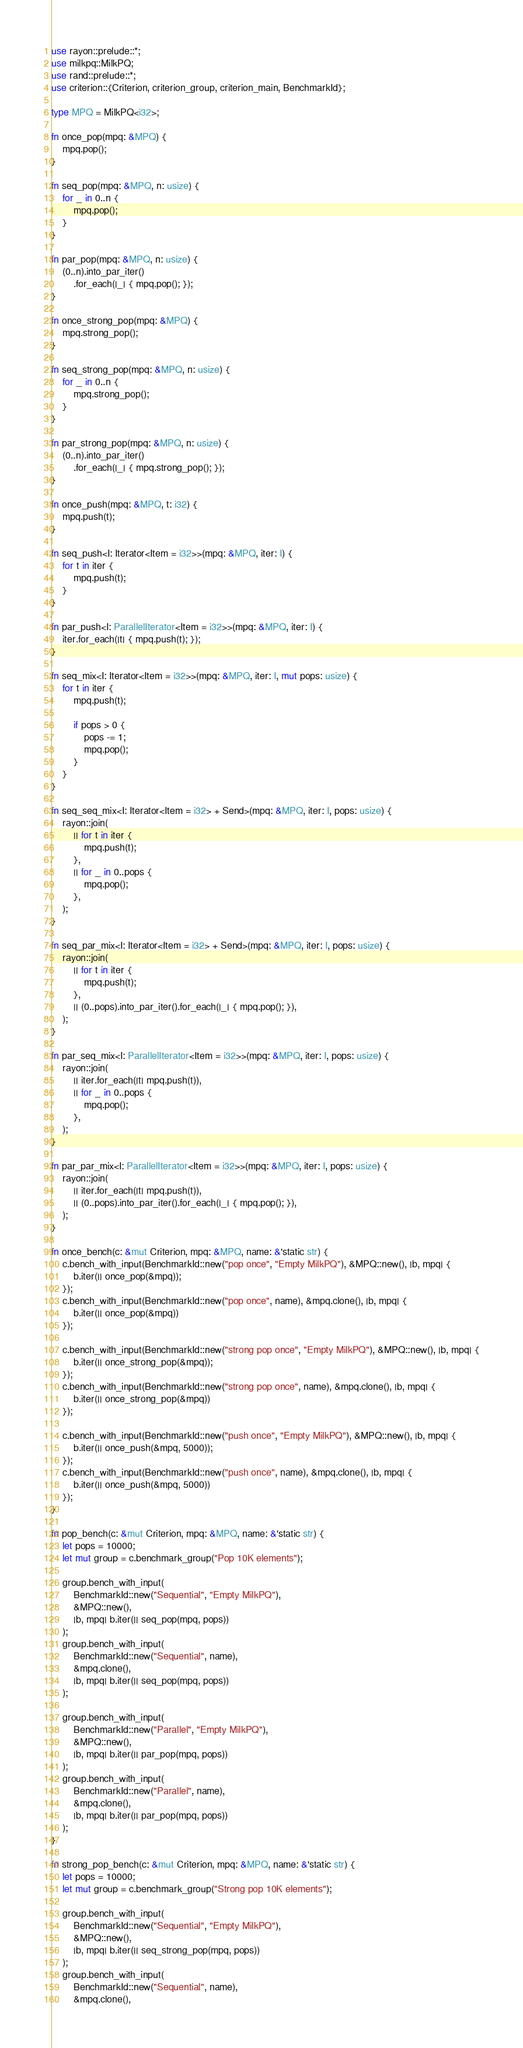<code> <loc_0><loc_0><loc_500><loc_500><_Rust_>use rayon::prelude::*;
use milkpq::MilkPQ;
use rand::prelude::*;
use criterion::{Criterion, criterion_group, criterion_main, BenchmarkId};

type MPQ = MilkPQ<i32>;

fn once_pop(mpq: &MPQ) {
    mpq.pop();
}

fn seq_pop(mpq: &MPQ, n: usize) {
    for _ in 0..n {
        mpq.pop();
    }
}

fn par_pop(mpq: &MPQ, n: usize) {
    (0..n).into_par_iter()
        .for_each(|_| { mpq.pop(); });
}

fn once_strong_pop(mpq: &MPQ) {
    mpq.strong_pop();
}

fn seq_strong_pop(mpq: &MPQ, n: usize) {
    for _ in 0..n {
        mpq.strong_pop();
    }
}

fn par_strong_pop(mpq: &MPQ, n: usize) {
    (0..n).into_par_iter()
        .for_each(|_| { mpq.strong_pop(); });
}

fn once_push(mpq: &MPQ, t: i32) {
    mpq.push(t);
}

fn seq_push<I: Iterator<Item = i32>>(mpq: &MPQ, iter: I) {
    for t in iter {
        mpq.push(t);
    }
}

fn par_push<I: ParallelIterator<Item = i32>>(mpq: &MPQ, iter: I) {
    iter.for_each(|t| { mpq.push(t); });
}

fn seq_mix<I: Iterator<Item = i32>>(mpq: &MPQ, iter: I, mut pops: usize) {
    for t in iter {
        mpq.push(t);
        
        if pops > 0 {
            pops -= 1;
            mpq.pop();
        }
    }
}

fn seq_seq_mix<I: Iterator<Item = i32> + Send>(mpq: &MPQ, iter: I, pops: usize) {
    rayon::join(
        || for t in iter {
            mpq.push(t);
        },
        || for _ in 0..pops {
            mpq.pop();
        },
    );
}

fn seq_par_mix<I: Iterator<Item = i32> + Send>(mpq: &MPQ, iter: I, pops: usize) {
    rayon::join(
        || for t in iter {
            mpq.push(t);
        },
        || (0..pops).into_par_iter().for_each(|_| { mpq.pop(); }),
    );
}

fn par_seq_mix<I: ParallelIterator<Item = i32>>(mpq: &MPQ, iter: I, pops: usize) {
    rayon::join(
        || iter.for_each(|t| mpq.push(t)),
        || for _ in 0..pops {
            mpq.pop();
        },
    );
}

fn par_par_mix<I: ParallelIterator<Item = i32>>(mpq: &MPQ, iter: I, pops: usize) {
    rayon::join(
        || iter.for_each(|t| mpq.push(t)),
        || (0..pops).into_par_iter().for_each(|_| { mpq.pop(); }),
    );
}

fn once_bench(c: &mut Criterion, mpq: &MPQ, name: &'static str) {
    c.bench_with_input(BenchmarkId::new("pop once", "Empty MilkPQ"), &MPQ::new(), |b, mpq| {
        b.iter(|| once_pop(&mpq));
    });
    c.bench_with_input(BenchmarkId::new("pop once", name), &mpq.clone(), |b, mpq| {
        b.iter(|| once_pop(&mpq))
    });

    c.bench_with_input(BenchmarkId::new("strong pop once", "Empty MilkPQ"), &MPQ::new(), |b, mpq| {
        b.iter(|| once_strong_pop(&mpq));
    });
    c.bench_with_input(BenchmarkId::new("strong pop once", name), &mpq.clone(), |b, mpq| {
        b.iter(|| once_strong_pop(&mpq))
    });

    c.bench_with_input(BenchmarkId::new("push once", "Empty MilkPQ"), &MPQ::new(), |b, mpq| {
        b.iter(|| once_push(&mpq, 5000));
    });
    c.bench_with_input(BenchmarkId::new("push once", name), &mpq.clone(), |b, mpq| {
        b.iter(|| once_push(&mpq, 5000))
    });
}

fn pop_bench(c: &mut Criterion, mpq: &MPQ, name: &'static str) {
    let pops = 10000;
    let mut group = c.benchmark_group("Pop 10K elements");

    group.bench_with_input(
        BenchmarkId::new("Sequential", "Empty MilkPQ"),
        &MPQ::new(),
        |b, mpq| b.iter(|| seq_pop(mpq, pops))
    );
    group.bench_with_input(
        BenchmarkId::new("Sequential", name),
        &mpq.clone(),
        |b, mpq| b.iter(|| seq_pop(mpq, pops))
    );

    group.bench_with_input(
        BenchmarkId::new("Parallel", "Empty MilkPQ"),
        &MPQ::new(),
        |b, mpq| b.iter(|| par_pop(mpq, pops))
    );
    group.bench_with_input(
        BenchmarkId::new("Parallel", name),
        &mpq.clone(),
        |b, mpq| b.iter(|| par_pop(mpq, pops))
    );
}

fn strong_pop_bench(c: &mut Criterion, mpq: &MPQ, name: &'static str) {
    let pops = 10000;
    let mut group = c.benchmark_group("Strong pop 10K elements");

    group.bench_with_input(
        BenchmarkId::new("Sequential", "Empty MilkPQ"),
        &MPQ::new(),
        |b, mpq| b.iter(|| seq_strong_pop(mpq, pops))
    );
    group.bench_with_input(
        BenchmarkId::new("Sequential", name),
        &mpq.clone(),</code> 